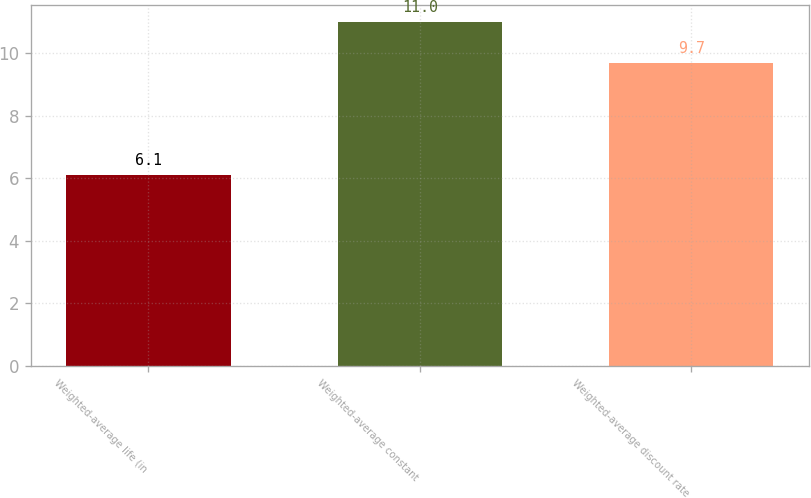Convert chart to OTSL. <chart><loc_0><loc_0><loc_500><loc_500><bar_chart><fcel>Weighted-average life (in<fcel>Weighted-average constant<fcel>Weighted-average discount rate<nl><fcel>6.1<fcel>11<fcel>9.7<nl></chart> 